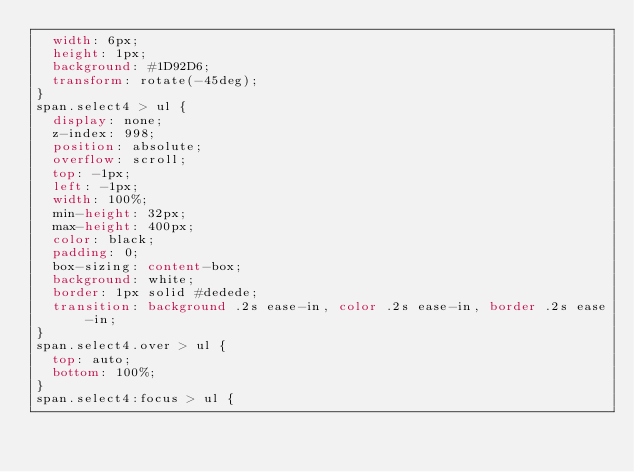Convert code to text. <code><loc_0><loc_0><loc_500><loc_500><_CSS_>  width: 6px;
  height: 1px;
  background: #1D92D6;
  transform: rotate(-45deg);
}
span.select4 > ul {
  display: none;
  z-index: 998;
  position: absolute;
  overflow: scroll;
  top: -1px;
  left: -1px;
  width: 100%;
  min-height: 32px;
  max-height: 400px;
  color: black;
  padding: 0;
  box-sizing: content-box;
  background: white;
  border: 1px solid #dedede;
  transition: background .2s ease-in, color .2s ease-in, border .2s ease-in;
}
span.select4.over > ul {
  top: auto;
  bottom: 100%; 
}
span.select4:focus > ul {</code> 